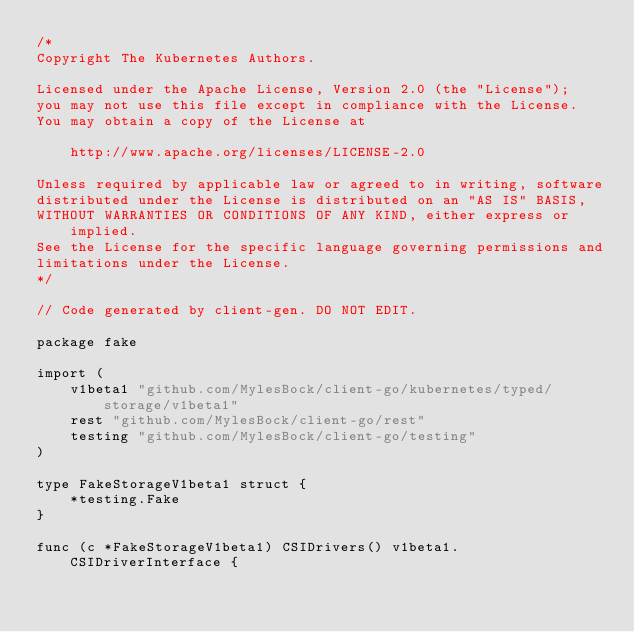Convert code to text. <code><loc_0><loc_0><loc_500><loc_500><_Go_>/*
Copyright The Kubernetes Authors.

Licensed under the Apache License, Version 2.0 (the "License");
you may not use this file except in compliance with the License.
You may obtain a copy of the License at

    http://www.apache.org/licenses/LICENSE-2.0

Unless required by applicable law or agreed to in writing, software
distributed under the License is distributed on an "AS IS" BASIS,
WITHOUT WARRANTIES OR CONDITIONS OF ANY KIND, either express or implied.
See the License for the specific language governing permissions and
limitations under the License.
*/

// Code generated by client-gen. DO NOT EDIT.

package fake

import (
	v1beta1 "github.com/MylesBock/client-go/kubernetes/typed/storage/v1beta1"
	rest "github.com/MylesBock/client-go/rest"
	testing "github.com/MylesBock/client-go/testing"
)

type FakeStorageV1beta1 struct {
	*testing.Fake
}

func (c *FakeStorageV1beta1) CSIDrivers() v1beta1.CSIDriverInterface {</code> 